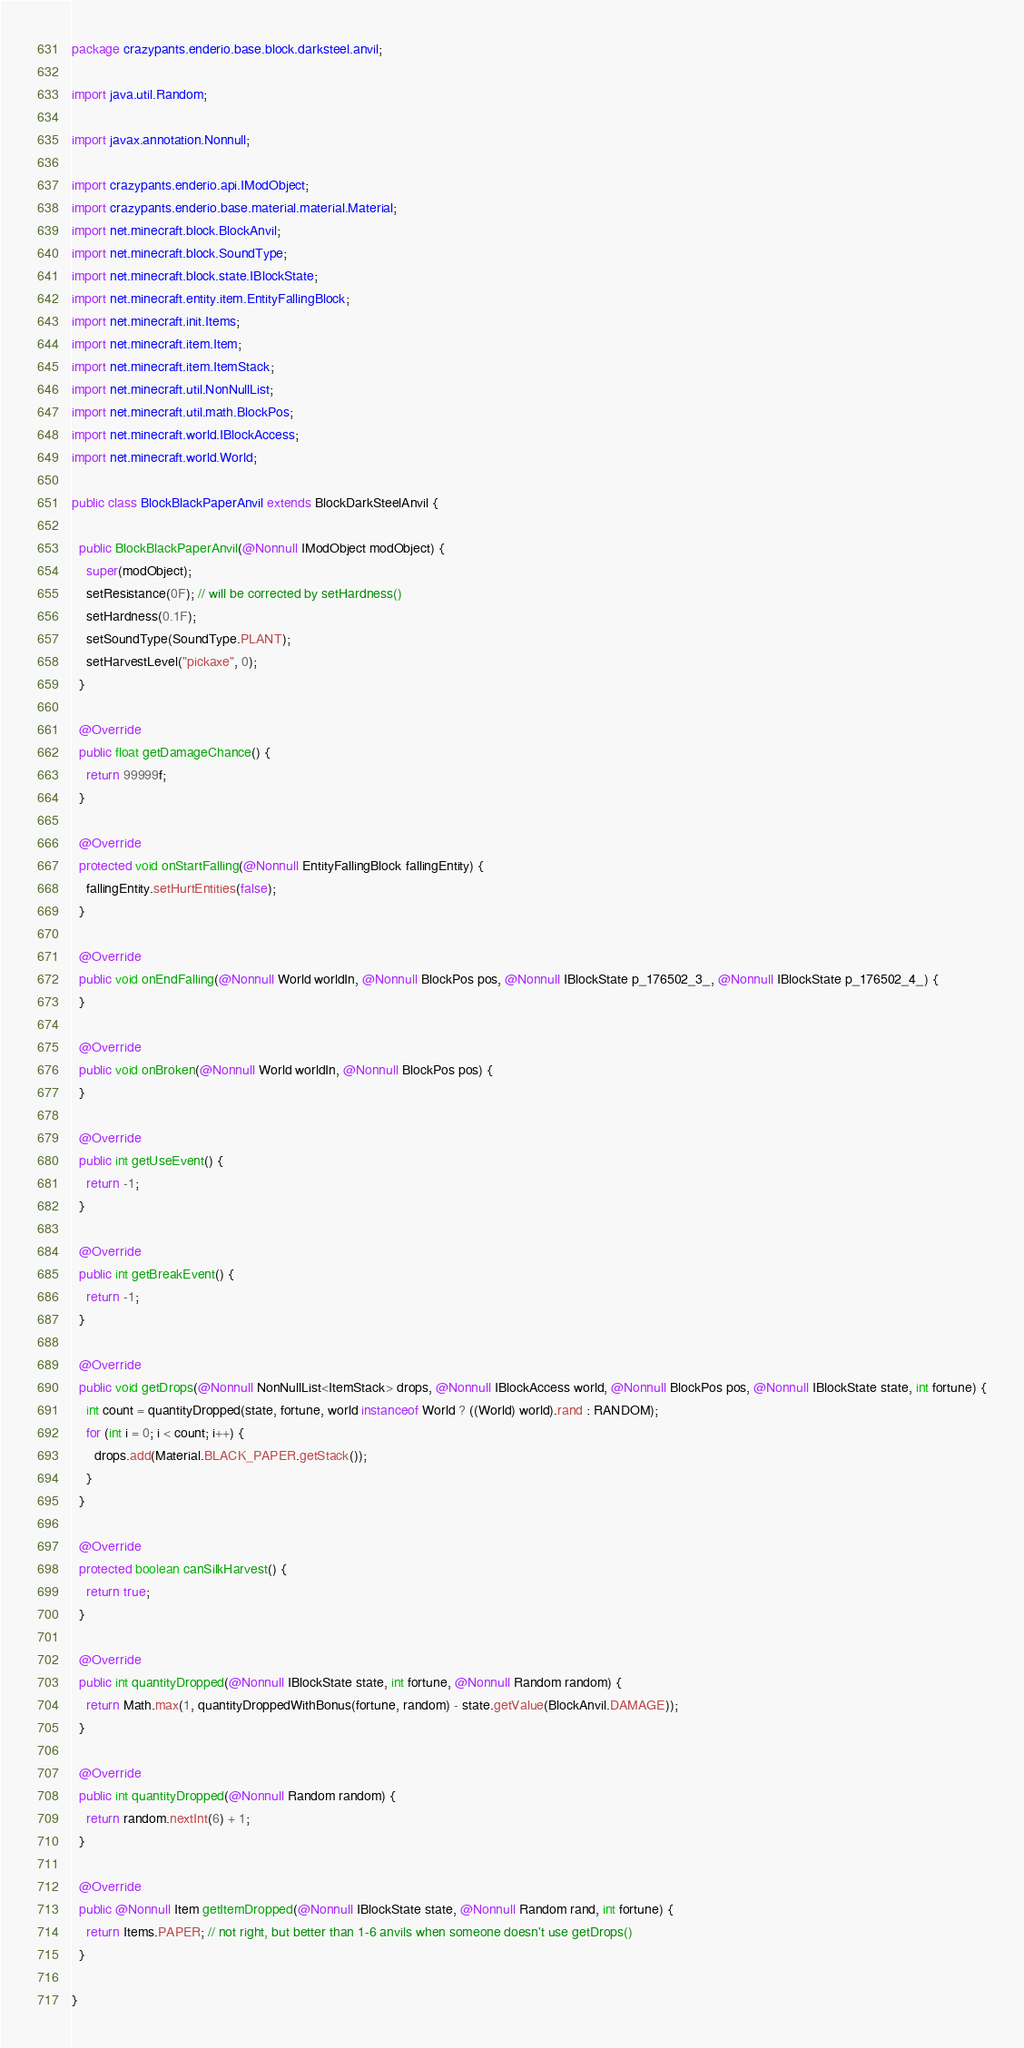<code> <loc_0><loc_0><loc_500><loc_500><_Java_>package crazypants.enderio.base.block.darksteel.anvil;

import java.util.Random;

import javax.annotation.Nonnull;

import crazypants.enderio.api.IModObject;
import crazypants.enderio.base.material.material.Material;
import net.minecraft.block.BlockAnvil;
import net.minecraft.block.SoundType;
import net.minecraft.block.state.IBlockState;
import net.minecraft.entity.item.EntityFallingBlock;
import net.minecraft.init.Items;
import net.minecraft.item.Item;
import net.minecraft.item.ItemStack;
import net.minecraft.util.NonNullList;
import net.minecraft.util.math.BlockPos;
import net.minecraft.world.IBlockAccess;
import net.minecraft.world.World;

public class BlockBlackPaperAnvil extends BlockDarkSteelAnvil {

  public BlockBlackPaperAnvil(@Nonnull IModObject modObject) {
    super(modObject);
    setResistance(0F); // will be corrected by setHardness()
    setHardness(0.1F);
    setSoundType(SoundType.PLANT);
    setHarvestLevel("pickaxe", 0);
  }

  @Override
  public float getDamageChance() {
    return 99999f;
  }

  @Override
  protected void onStartFalling(@Nonnull EntityFallingBlock fallingEntity) {
    fallingEntity.setHurtEntities(false);
  }

  @Override
  public void onEndFalling(@Nonnull World worldIn, @Nonnull BlockPos pos, @Nonnull IBlockState p_176502_3_, @Nonnull IBlockState p_176502_4_) {
  }

  @Override
  public void onBroken(@Nonnull World worldIn, @Nonnull BlockPos pos) {
  }

  @Override
  public int getUseEvent() {
    return -1;
  }

  @Override
  public int getBreakEvent() {
    return -1;
  }

  @Override
  public void getDrops(@Nonnull NonNullList<ItemStack> drops, @Nonnull IBlockAccess world, @Nonnull BlockPos pos, @Nonnull IBlockState state, int fortune) {
    int count = quantityDropped(state, fortune, world instanceof World ? ((World) world).rand : RANDOM);
    for (int i = 0; i < count; i++) {
      drops.add(Material.BLACK_PAPER.getStack());
    }
  }

  @Override
  protected boolean canSilkHarvest() {
    return true;
  }

  @Override
  public int quantityDropped(@Nonnull IBlockState state, int fortune, @Nonnull Random random) {
    return Math.max(1, quantityDroppedWithBonus(fortune, random) - state.getValue(BlockAnvil.DAMAGE));
  }

  @Override
  public int quantityDropped(@Nonnull Random random) {
    return random.nextInt(6) + 1;
  }

  @Override
  public @Nonnull Item getItemDropped(@Nonnull IBlockState state, @Nonnull Random rand, int fortune) {
    return Items.PAPER; // not right, but better than 1-6 anvils when someone doesn't use getDrops()
  }

}
</code> 